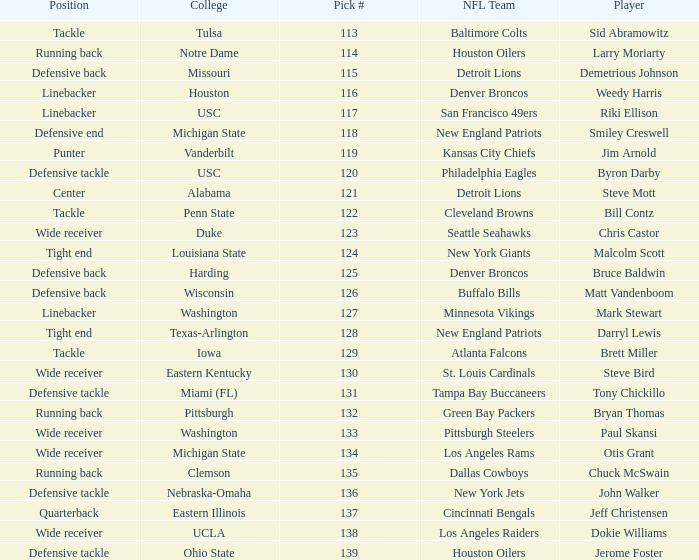What was bruce baldwin's pick #? 125.0. 